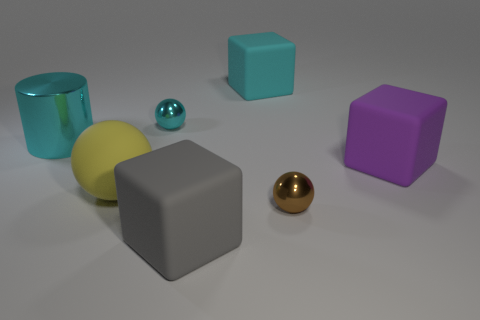Can you describe the lighting and shadows in the scene? The scene is lit from above, casting soft-edged shadows that emanate diagonally to the bottom left. The lighting suggests a singular diffuse light source, perhaps resembling an overcast sky or a large softbox. The softness of the shadows indicates that the light source is not extremely close to the objects. How might this lighting impact the mood or setting of the image? This type of diffuse and soft lighting creates a calm and neutral atmosphere in the image. It gives the scene a controlled and almost clinical appearance, often used in product photography or to showcase objects without emotional weight or narrative. 